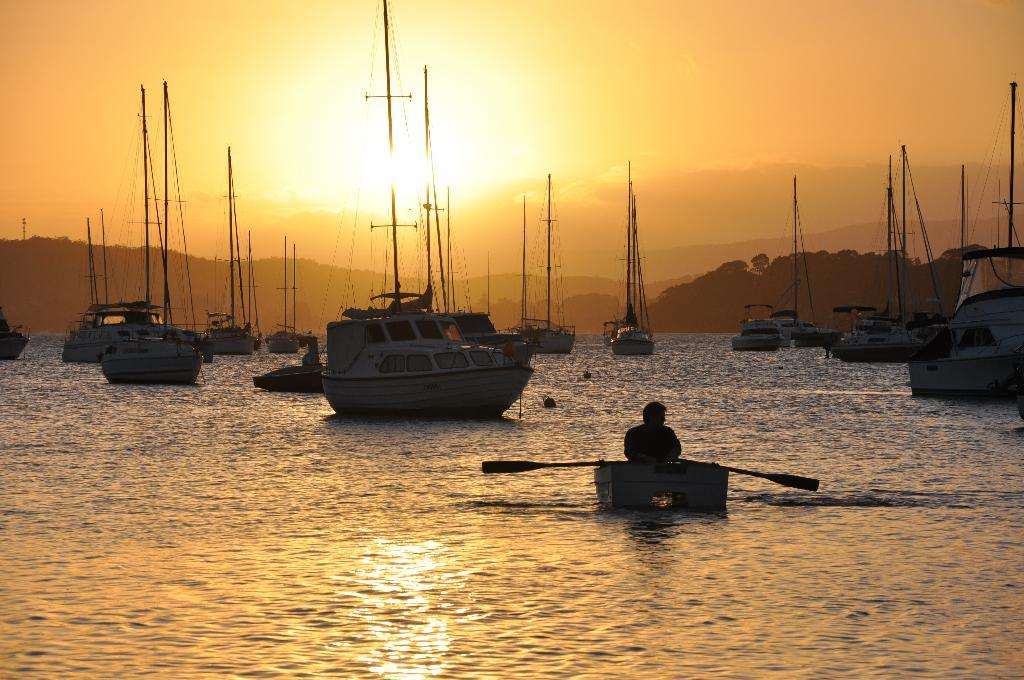What is located in the middle of the picture? There is a fleet in the middle of the picture. What is the primary feature of the fleet? The fleet consists of boats or ships. What is the natural feature that runs through the middle of the picture? There is a river in the middle of the picture. What can be seen in the background of the picture? There are hills and the sky visible in the background of the picture. What type of juice can be seen being poured from a pitcher in the image? There is no pitcher or juice present in the image. What color is the curtain hanging in the background of the image? There is no curtain present in the image; the background features hills and the sky. 